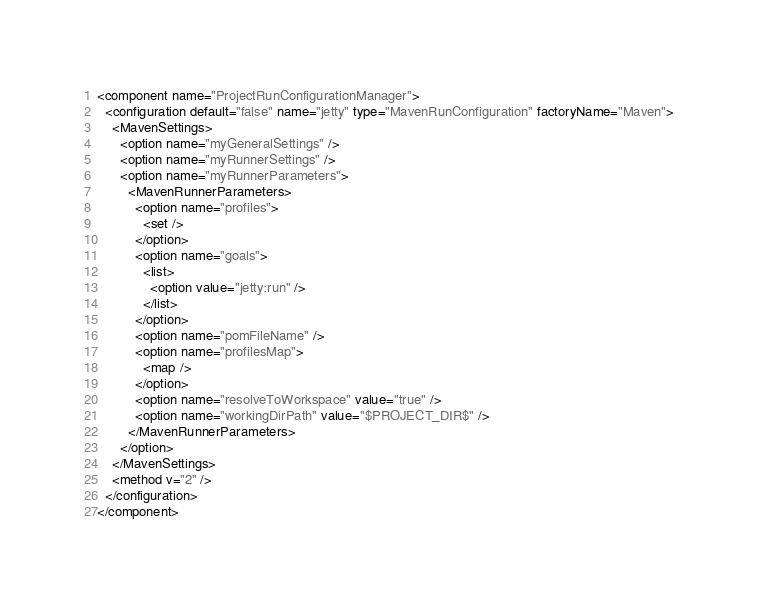<code> <loc_0><loc_0><loc_500><loc_500><_XML_><component name="ProjectRunConfigurationManager">
  <configuration default="false" name="jetty" type="MavenRunConfiguration" factoryName="Maven">
    <MavenSettings>
      <option name="myGeneralSettings" />
      <option name="myRunnerSettings" />
      <option name="myRunnerParameters">
        <MavenRunnerParameters>
          <option name="profiles">
            <set />
          </option>
          <option name="goals">
            <list>
              <option value="jetty:run" />
            </list>
          </option>
          <option name="pomFileName" />
          <option name="profilesMap">
            <map />
          </option>
          <option name="resolveToWorkspace" value="true" />
          <option name="workingDirPath" value="$PROJECT_DIR$" />
        </MavenRunnerParameters>
      </option>
    </MavenSettings>
    <method v="2" />
  </configuration>
</component></code> 